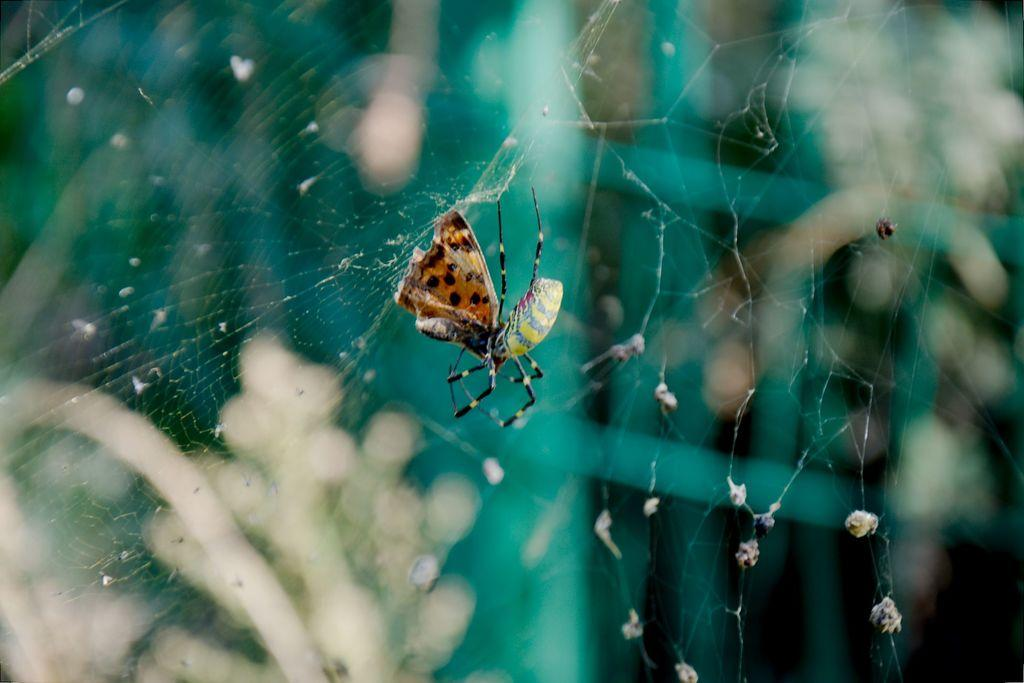What type of insects can be seen in the image? There is a spider and a butterfly in the image. Where are the spider and butterfly located? The spider and butterfly are on a web. What are the children writing on the web in the image? There are no children present in the image, and therefore no writing can be observed. 